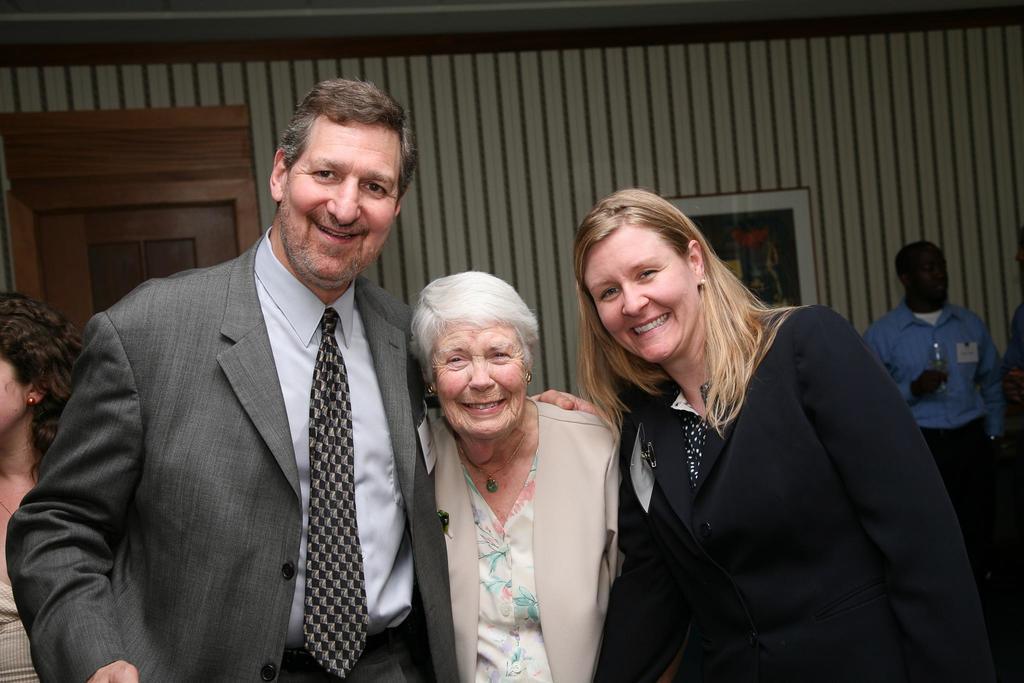How would you summarize this image in a sentence or two? In this image we can see a man and two women are standing and all of them are smiling. In the background there are few persons, doors and a frame on the wall. On the right side we can see a man is holding a glass in his hand. 